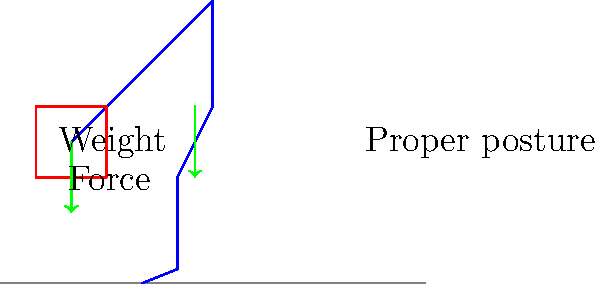As a retired firefighter, you know the importance of proper lifting techniques. In the diagram, a firefighter is lifting a heavy piece of equipment. What is the primary biomechanical principle illustrated that helps reduce the risk of back injury? To understand the biomechanical principle illustrated in the diagram, let's break it down step-by-step:

1. Posture: The firefighter is shown with a straight back, bending at the hips and knees rather than rounding the spine.

2. Center of gravity: The equipment is kept close to the body, reducing the moment arm and thus the torque on the spine.

3. Force distribution: The legs, particularly the strong quadriceps muscles, are engaged in the lift rather than relying solely on the back muscles.

4. Lever principle: By keeping the load close to the body, the firefighter reduces the effective lever arm, decreasing the force required to lift the equipment.

5. Balance: The firefighter's feet are positioned shoulder-width apart, providing a stable base of support.

6. Force vectors: The green arrows in the diagram show the direction of force application - one upward from the legs and one inward from the arms, creating a resultant force that efficiently lifts the equipment.

The primary biomechanical principle illustrated here is the reduction of spinal loading by maintaining a neutral spine position and using the stronger leg muscles to generate the lifting force. This technique, often referred to as a "squat lift" or "power lift," minimizes the shear and compressive forces on the intervertebral discs and reduces the risk of back injury.
Answer: Neutral spine position and leg muscle engagement 